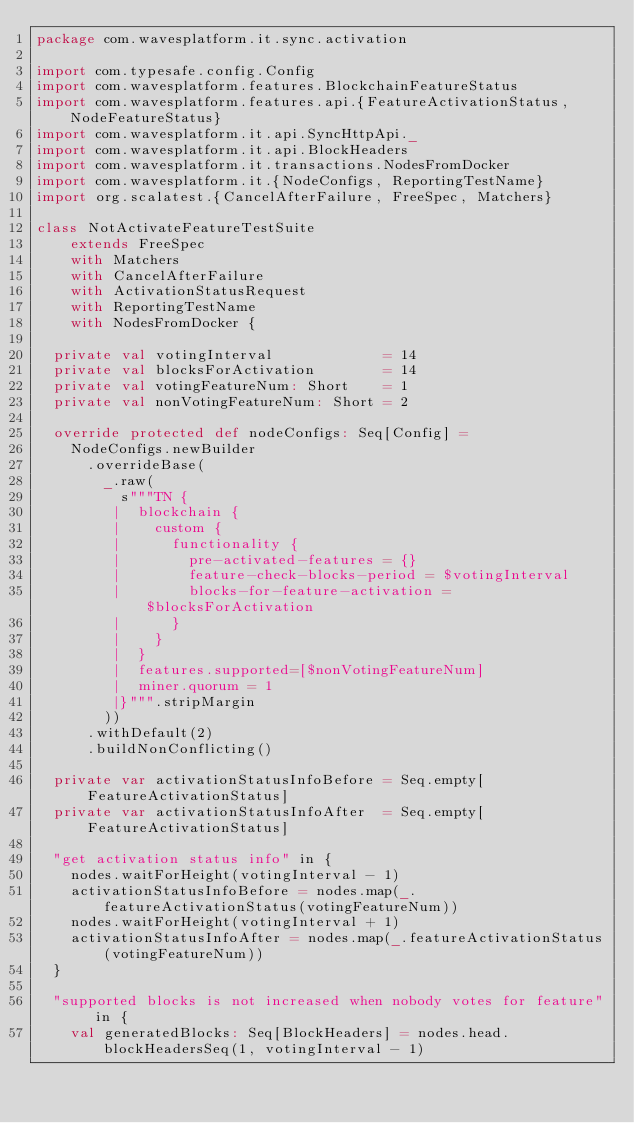Convert code to text. <code><loc_0><loc_0><loc_500><loc_500><_Scala_>package com.wavesplatform.it.sync.activation

import com.typesafe.config.Config
import com.wavesplatform.features.BlockchainFeatureStatus
import com.wavesplatform.features.api.{FeatureActivationStatus, NodeFeatureStatus}
import com.wavesplatform.it.api.SyncHttpApi._
import com.wavesplatform.it.api.BlockHeaders
import com.wavesplatform.it.transactions.NodesFromDocker
import com.wavesplatform.it.{NodeConfigs, ReportingTestName}
import org.scalatest.{CancelAfterFailure, FreeSpec, Matchers}

class NotActivateFeatureTestSuite
    extends FreeSpec
    with Matchers
    with CancelAfterFailure
    with ActivationStatusRequest
    with ReportingTestName
    with NodesFromDocker {

  private val votingInterval             = 14
  private val blocksForActivation        = 14
  private val votingFeatureNum: Short    = 1
  private val nonVotingFeatureNum: Short = 2

  override protected def nodeConfigs: Seq[Config] =
    NodeConfigs.newBuilder
      .overrideBase(
        _.raw(
          s"""TN {
         |  blockchain {
         |    custom {
         |      functionality {
         |        pre-activated-features = {}
         |        feature-check-blocks-period = $votingInterval
         |        blocks-for-feature-activation = $blocksForActivation
         |      }
         |    }
         |  }
         |  features.supported=[$nonVotingFeatureNum]
         |  miner.quorum = 1
         |}""".stripMargin
        ))
      .withDefault(2)
      .buildNonConflicting()

  private var activationStatusInfoBefore = Seq.empty[FeatureActivationStatus]
  private var activationStatusInfoAfter  = Seq.empty[FeatureActivationStatus]

  "get activation status info" in {
    nodes.waitForHeight(votingInterval - 1)
    activationStatusInfoBefore = nodes.map(_.featureActivationStatus(votingFeatureNum))
    nodes.waitForHeight(votingInterval + 1)
    activationStatusInfoAfter = nodes.map(_.featureActivationStatus(votingFeatureNum))
  }

  "supported blocks is not increased when nobody votes for feature" in {
    val generatedBlocks: Seq[BlockHeaders] = nodes.head.blockHeadersSeq(1, votingInterval - 1)</code> 